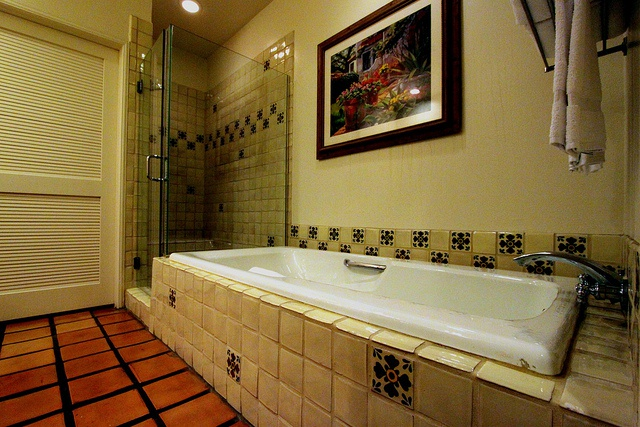Describe the objects in this image and their specific colors. I can see various objects in this image with different colors. 